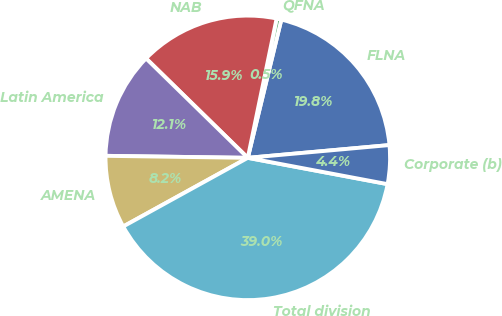Convert chart to OTSL. <chart><loc_0><loc_0><loc_500><loc_500><pie_chart><fcel>FLNA<fcel>QFNA<fcel>NAB<fcel>Latin America<fcel>AMENA<fcel>Total division<fcel>Corporate (b)<nl><fcel>19.78%<fcel>0.54%<fcel>15.93%<fcel>12.09%<fcel>8.24%<fcel>39.02%<fcel>4.39%<nl></chart> 